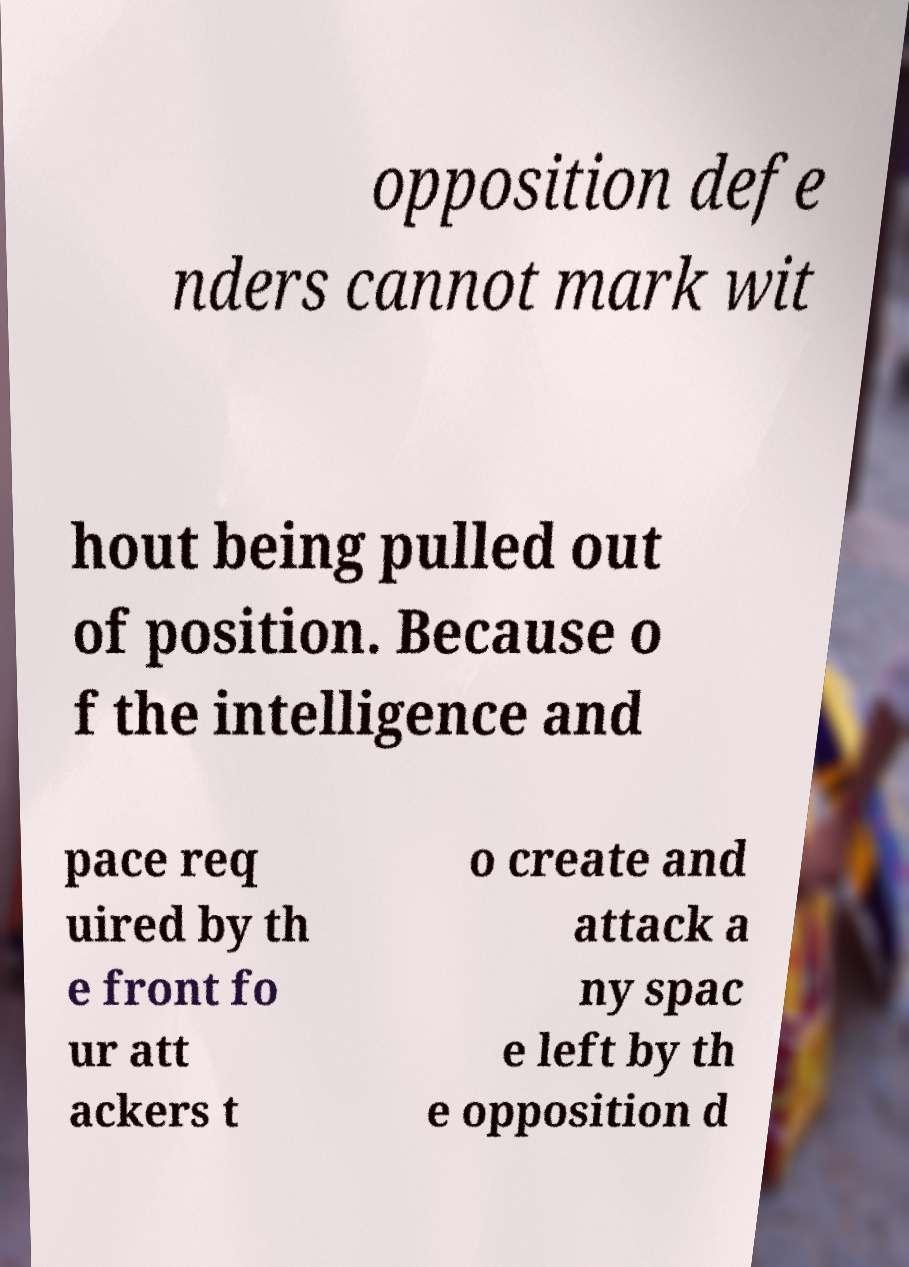Could you extract and type out the text from this image? opposition defe nders cannot mark wit hout being pulled out of position. Because o f the intelligence and pace req uired by th e front fo ur att ackers t o create and attack a ny spac e left by th e opposition d 